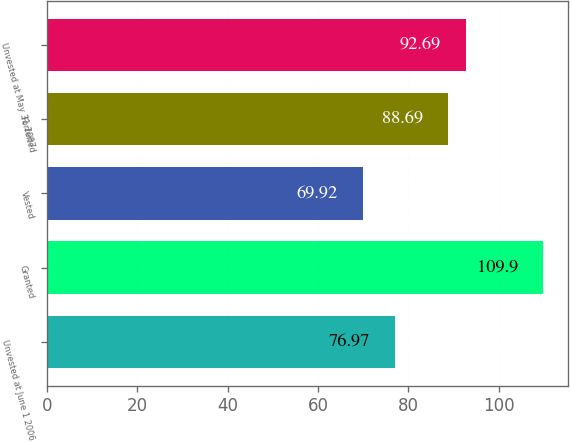Convert chart to OTSL. <chart><loc_0><loc_0><loc_500><loc_500><bar_chart><fcel>Unvested at June 1 2006<fcel>Granted<fcel>Vested<fcel>Forfeited<fcel>Unvested at May 31 2007<nl><fcel>76.97<fcel>109.9<fcel>69.92<fcel>88.69<fcel>92.69<nl></chart> 